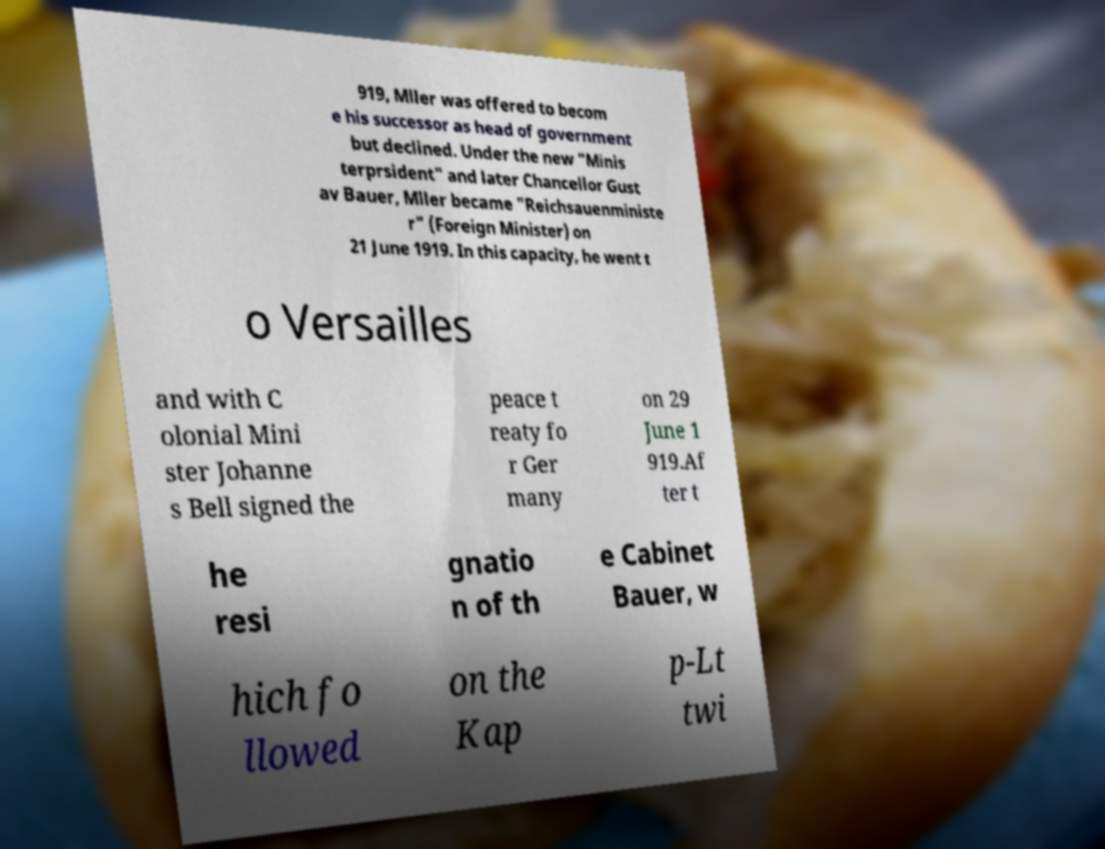Please identify and transcribe the text found in this image. 919, Mller was offered to becom e his successor as head of government but declined. Under the new "Minis terprsident" and later Chancellor Gust av Bauer, Mller became "Reichsauenministe r" (Foreign Minister) on 21 June 1919. In this capacity, he went t o Versailles and with C olonial Mini ster Johanne s Bell signed the peace t reaty fo r Ger many on 29 June 1 919.Af ter t he resi gnatio n of th e Cabinet Bauer, w hich fo llowed on the Kap p-Lt twi 